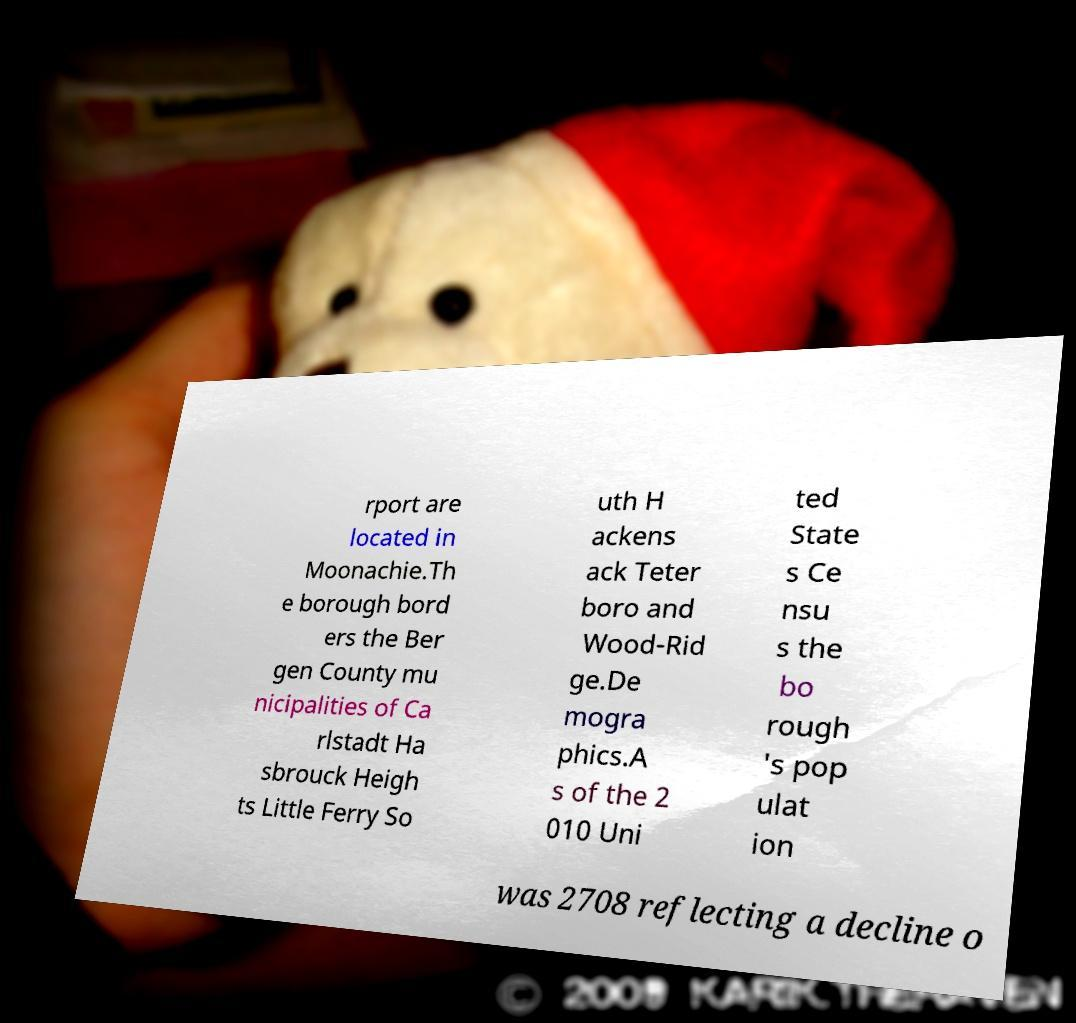I need the written content from this picture converted into text. Can you do that? rport are located in Moonachie.Th e borough bord ers the Ber gen County mu nicipalities of Ca rlstadt Ha sbrouck Heigh ts Little Ferry So uth H ackens ack Teter boro and Wood-Rid ge.De mogra phics.A s of the 2 010 Uni ted State s Ce nsu s the bo rough 's pop ulat ion was 2708 reflecting a decline o 